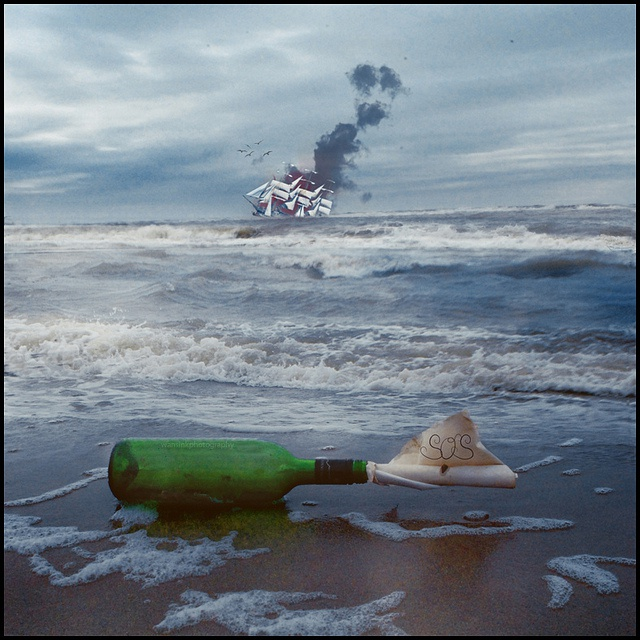Describe the objects in this image and their specific colors. I can see bottle in black, darkgreen, and teal tones, boat in black, gray, lightgray, and darkgray tones, bird in black, darkgray, and gray tones, bird in black, gray, and blue tones, and bird in black, gray, and darkgray tones in this image. 